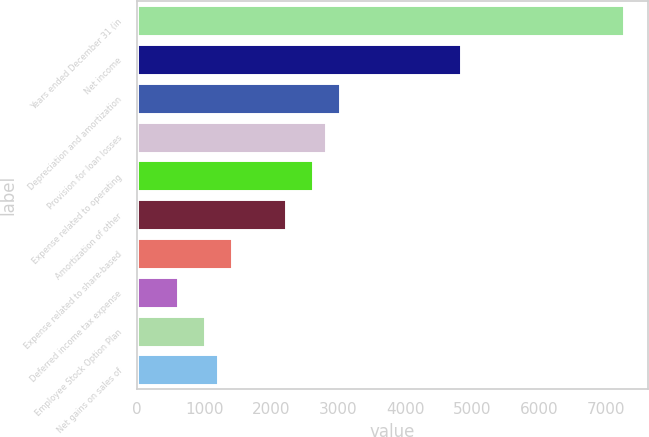<chart> <loc_0><loc_0><loc_500><loc_500><bar_chart><fcel>Years ended December 31 (in<fcel>Net income<fcel>Depreciation and amortization<fcel>Provision for loan losses<fcel>Expense related to operating<fcel>Amortization of other<fcel>Expense related to share-based<fcel>Deferred income tax expense<fcel>Employee Stock Option Plan<fcel>Net gains on sales of<nl><fcel>7257.08<fcel>4838.12<fcel>3023.9<fcel>2822.32<fcel>2620.74<fcel>2217.58<fcel>1411.26<fcel>604.94<fcel>1008.1<fcel>1209.68<nl></chart> 